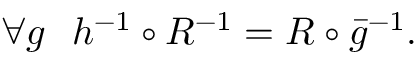Convert formula to latex. <formula><loc_0><loc_0><loc_500><loc_500>\begin{array} { r } { \forall g \ \ h ^ { - 1 } \circ R ^ { - 1 } = R \circ \bar { g } ^ { - 1 } . } \end{array}</formula> 